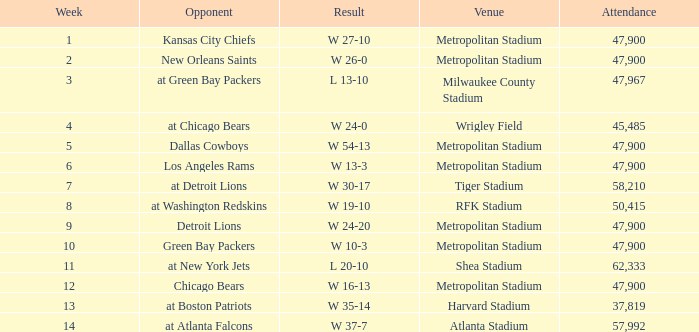How many people attended the game with a result of w 16-13 and a week earlier than 12? None. 